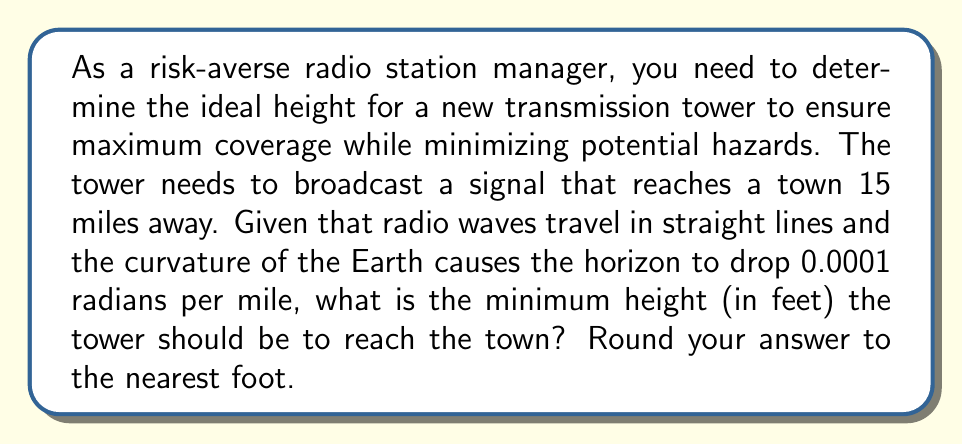Can you answer this question? Let's approach this step-by-step:

1) First, we need to understand the problem:
   - The tower needs to reach a town 15 miles away
   - The Earth's curvature causes a drop of 0.0001 radians per mile

2) We can model this situation using a right triangle, where:
   - The base of the triangle is the distance to the town (15 miles)
   - The angle between the base and the hypotenuse is the total drop due to Earth's curvature
   - The height of the tower is the opposite side of this angle

3) Calculate the total angle of drop:
   $$ \text{Total angle} = 15 \text{ miles} \times 0.0001 \text{ radians/mile} = 0.0015 \text{ radians} $$

4) Now we can use the tangent function to find the height:
   $$ \tan(\theta) = \frac{\text{opposite}}{\text{adjacent}} = \frac{\text{tower height}}{\text{distance to town}} $$

5) Rearranging this equation:
   $$ \text{tower height} = \text{distance to town} \times \tan(\theta) $$

6) Plugging in our values:
   $$ \text{tower height} = 15 \text{ miles} \times \tan(0.0015) $$

7) Calculate:
   $$ \text{tower height} = 15 \times 0.0015000112500422 = 0.0225001687506335 \text{ miles} $$

8) Convert to feet (1 mile = 5280 feet):
   $$ 0.0225001687506335 \times 5280 = 118.8008897227048 \text{ feet} $$

9) Rounding to the nearest foot:
   $$ 119 \text{ feet} $$
Answer: 119 feet 